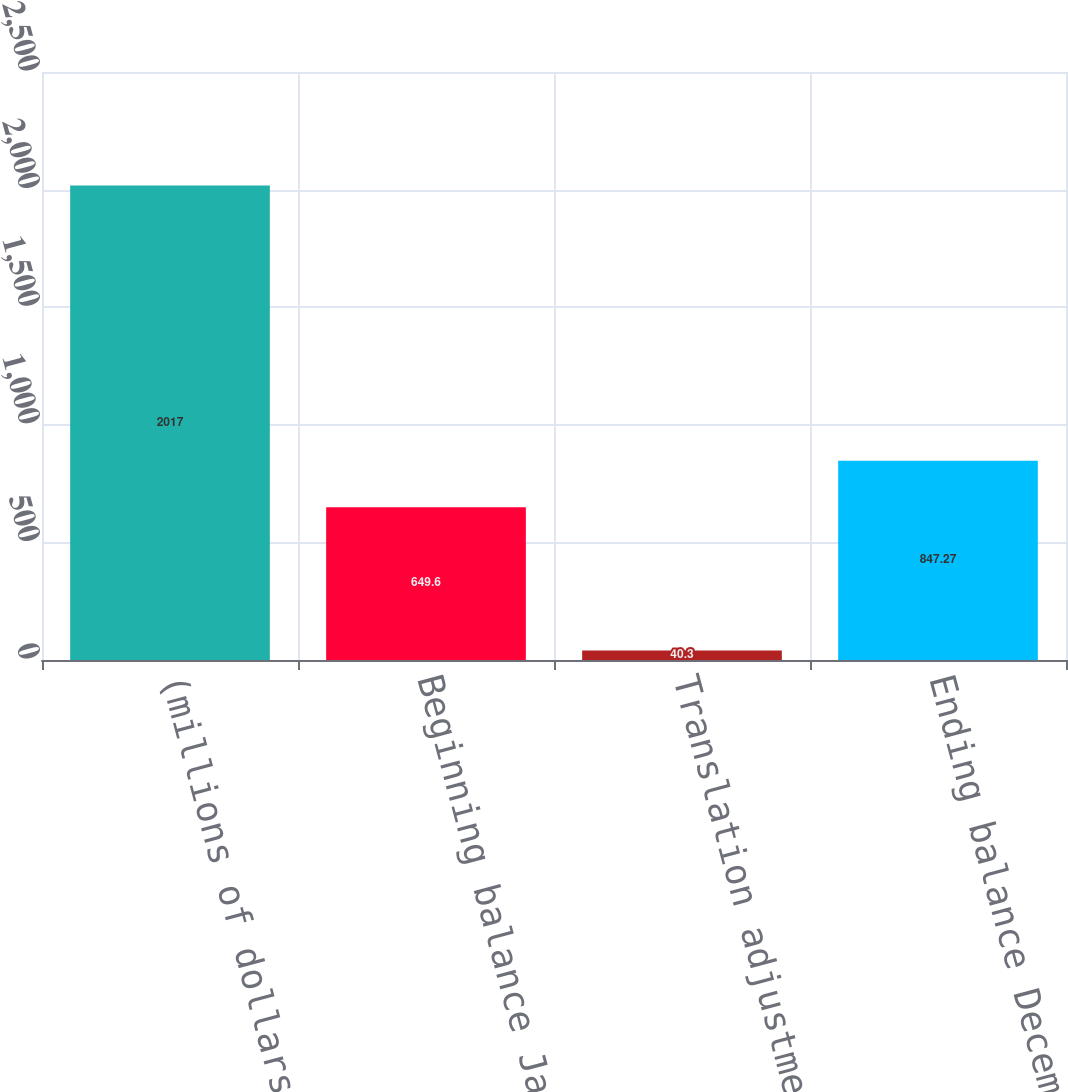Convert chart. <chart><loc_0><loc_0><loc_500><loc_500><bar_chart><fcel>(millions of dollars)<fcel>Beginning balance January 1<fcel>Translation adjustment<fcel>Ending balance December 31<nl><fcel>2017<fcel>649.6<fcel>40.3<fcel>847.27<nl></chart> 